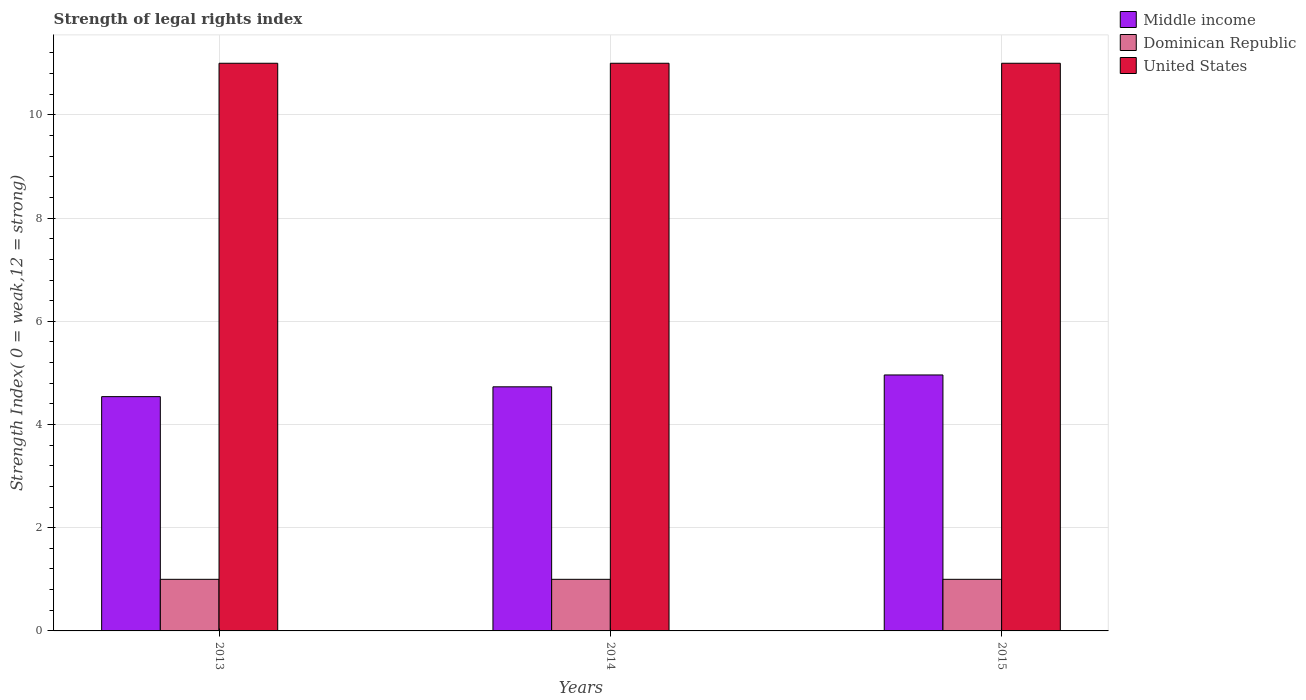How many different coloured bars are there?
Provide a succinct answer. 3. How many groups of bars are there?
Your response must be concise. 3. What is the label of the 3rd group of bars from the left?
Your answer should be very brief. 2015. What is the strength index in United States in 2013?
Keep it short and to the point. 11. Across all years, what is the maximum strength index in United States?
Offer a terse response. 11. Across all years, what is the minimum strength index in Dominican Republic?
Ensure brevity in your answer.  1. What is the total strength index in Dominican Republic in the graph?
Your answer should be very brief. 3. What is the difference between the strength index in United States in 2015 and the strength index in Dominican Republic in 2013?
Give a very brief answer. 10. In the year 2014, what is the difference between the strength index in United States and strength index in Dominican Republic?
Keep it short and to the point. 10. Is the difference between the strength index in United States in 2013 and 2015 greater than the difference between the strength index in Dominican Republic in 2013 and 2015?
Provide a short and direct response. No. In how many years, is the strength index in United States greater than the average strength index in United States taken over all years?
Offer a very short reply. 0. Is the sum of the strength index in Dominican Republic in 2013 and 2015 greater than the maximum strength index in Middle income across all years?
Provide a short and direct response. No. What does the 1st bar from the right in 2014 represents?
Offer a terse response. United States. How many bars are there?
Provide a succinct answer. 9. Are all the bars in the graph horizontal?
Keep it short and to the point. No. How many years are there in the graph?
Keep it short and to the point. 3. Does the graph contain any zero values?
Give a very brief answer. No. Where does the legend appear in the graph?
Keep it short and to the point. Top right. How many legend labels are there?
Your response must be concise. 3. How are the legend labels stacked?
Offer a terse response. Vertical. What is the title of the graph?
Provide a short and direct response. Strength of legal rights index. Does "North America" appear as one of the legend labels in the graph?
Provide a succinct answer. No. What is the label or title of the X-axis?
Your response must be concise. Years. What is the label or title of the Y-axis?
Make the answer very short. Strength Index( 0 = weak,12 = strong). What is the Strength Index( 0 = weak,12 = strong) in Middle income in 2013?
Ensure brevity in your answer.  4.54. What is the Strength Index( 0 = weak,12 = strong) in Middle income in 2014?
Give a very brief answer. 4.73. What is the Strength Index( 0 = weak,12 = strong) in Dominican Republic in 2014?
Your answer should be very brief. 1. What is the Strength Index( 0 = weak,12 = strong) of Middle income in 2015?
Provide a succinct answer. 4.96. Across all years, what is the maximum Strength Index( 0 = weak,12 = strong) in Middle income?
Ensure brevity in your answer.  4.96. Across all years, what is the maximum Strength Index( 0 = weak,12 = strong) in Dominican Republic?
Keep it short and to the point. 1. Across all years, what is the minimum Strength Index( 0 = weak,12 = strong) of Middle income?
Make the answer very short. 4.54. Across all years, what is the minimum Strength Index( 0 = weak,12 = strong) in Dominican Republic?
Your answer should be very brief. 1. Across all years, what is the minimum Strength Index( 0 = weak,12 = strong) of United States?
Ensure brevity in your answer.  11. What is the total Strength Index( 0 = weak,12 = strong) of Middle income in the graph?
Your answer should be very brief. 14.23. What is the total Strength Index( 0 = weak,12 = strong) of Dominican Republic in the graph?
Your answer should be compact. 3. What is the total Strength Index( 0 = weak,12 = strong) in United States in the graph?
Your response must be concise. 33. What is the difference between the Strength Index( 0 = weak,12 = strong) of Middle income in 2013 and that in 2014?
Provide a short and direct response. -0.19. What is the difference between the Strength Index( 0 = weak,12 = strong) in Dominican Republic in 2013 and that in 2014?
Give a very brief answer. 0. What is the difference between the Strength Index( 0 = weak,12 = strong) of United States in 2013 and that in 2014?
Ensure brevity in your answer.  0. What is the difference between the Strength Index( 0 = weak,12 = strong) in Middle income in 2013 and that in 2015?
Ensure brevity in your answer.  -0.42. What is the difference between the Strength Index( 0 = weak,12 = strong) of Dominican Republic in 2013 and that in 2015?
Provide a succinct answer. 0. What is the difference between the Strength Index( 0 = weak,12 = strong) of Middle income in 2014 and that in 2015?
Offer a very short reply. -0.23. What is the difference between the Strength Index( 0 = weak,12 = strong) of Middle income in 2013 and the Strength Index( 0 = weak,12 = strong) of Dominican Republic in 2014?
Provide a short and direct response. 3.54. What is the difference between the Strength Index( 0 = weak,12 = strong) of Middle income in 2013 and the Strength Index( 0 = weak,12 = strong) of United States in 2014?
Your answer should be very brief. -6.46. What is the difference between the Strength Index( 0 = weak,12 = strong) of Dominican Republic in 2013 and the Strength Index( 0 = weak,12 = strong) of United States in 2014?
Provide a short and direct response. -10. What is the difference between the Strength Index( 0 = weak,12 = strong) in Middle income in 2013 and the Strength Index( 0 = weak,12 = strong) in Dominican Republic in 2015?
Give a very brief answer. 3.54. What is the difference between the Strength Index( 0 = weak,12 = strong) in Middle income in 2013 and the Strength Index( 0 = weak,12 = strong) in United States in 2015?
Offer a terse response. -6.46. What is the difference between the Strength Index( 0 = weak,12 = strong) in Dominican Republic in 2013 and the Strength Index( 0 = weak,12 = strong) in United States in 2015?
Ensure brevity in your answer.  -10. What is the difference between the Strength Index( 0 = weak,12 = strong) of Middle income in 2014 and the Strength Index( 0 = weak,12 = strong) of Dominican Republic in 2015?
Your response must be concise. 3.73. What is the difference between the Strength Index( 0 = weak,12 = strong) of Middle income in 2014 and the Strength Index( 0 = weak,12 = strong) of United States in 2015?
Your response must be concise. -6.27. What is the average Strength Index( 0 = weak,12 = strong) in Middle income per year?
Provide a succinct answer. 4.74. What is the average Strength Index( 0 = weak,12 = strong) of Dominican Republic per year?
Your response must be concise. 1. What is the average Strength Index( 0 = weak,12 = strong) in United States per year?
Provide a short and direct response. 11. In the year 2013, what is the difference between the Strength Index( 0 = weak,12 = strong) in Middle income and Strength Index( 0 = weak,12 = strong) in Dominican Republic?
Your response must be concise. 3.54. In the year 2013, what is the difference between the Strength Index( 0 = weak,12 = strong) in Middle income and Strength Index( 0 = weak,12 = strong) in United States?
Give a very brief answer. -6.46. In the year 2013, what is the difference between the Strength Index( 0 = weak,12 = strong) of Dominican Republic and Strength Index( 0 = weak,12 = strong) of United States?
Make the answer very short. -10. In the year 2014, what is the difference between the Strength Index( 0 = weak,12 = strong) of Middle income and Strength Index( 0 = weak,12 = strong) of Dominican Republic?
Offer a very short reply. 3.73. In the year 2014, what is the difference between the Strength Index( 0 = weak,12 = strong) in Middle income and Strength Index( 0 = weak,12 = strong) in United States?
Your answer should be very brief. -6.27. In the year 2015, what is the difference between the Strength Index( 0 = weak,12 = strong) of Middle income and Strength Index( 0 = weak,12 = strong) of Dominican Republic?
Provide a succinct answer. 3.96. In the year 2015, what is the difference between the Strength Index( 0 = weak,12 = strong) in Middle income and Strength Index( 0 = weak,12 = strong) in United States?
Offer a terse response. -6.04. In the year 2015, what is the difference between the Strength Index( 0 = weak,12 = strong) of Dominican Republic and Strength Index( 0 = weak,12 = strong) of United States?
Provide a short and direct response. -10. What is the ratio of the Strength Index( 0 = weak,12 = strong) in Middle income in 2013 to that in 2014?
Your answer should be very brief. 0.96. What is the ratio of the Strength Index( 0 = weak,12 = strong) in Dominican Republic in 2013 to that in 2014?
Make the answer very short. 1. What is the ratio of the Strength Index( 0 = weak,12 = strong) in Middle income in 2013 to that in 2015?
Offer a very short reply. 0.92. What is the ratio of the Strength Index( 0 = weak,12 = strong) of Dominican Republic in 2013 to that in 2015?
Make the answer very short. 1. What is the ratio of the Strength Index( 0 = weak,12 = strong) of United States in 2013 to that in 2015?
Provide a short and direct response. 1. What is the ratio of the Strength Index( 0 = weak,12 = strong) in Middle income in 2014 to that in 2015?
Give a very brief answer. 0.95. What is the ratio of the Strength Index( 0 = weak,12 = strong) of Dominican Republic in 2014 to that in 2015?
Offer a very short reply. 1. What is the ratio of the Strength Index( 0 = weak,12 = strong) in United States in 2014 to that in 2015?
Provide a succinct answer. 1. What is the difference between the highest and the second highest Strength Index( 0 = weak,12 = strong) of Middle income?
Offer a very short reply. 0.23. What is the difference between the highest and the lowest Strength Index( 0 = weak,12 = strong) of Middle income?
Provide a succinct answer. 0.42. What is the difference between the highest and the lowest Strength Index( 0 = weak,12 = strong) in Dominican Republic?
Offer a terse response. 0. 